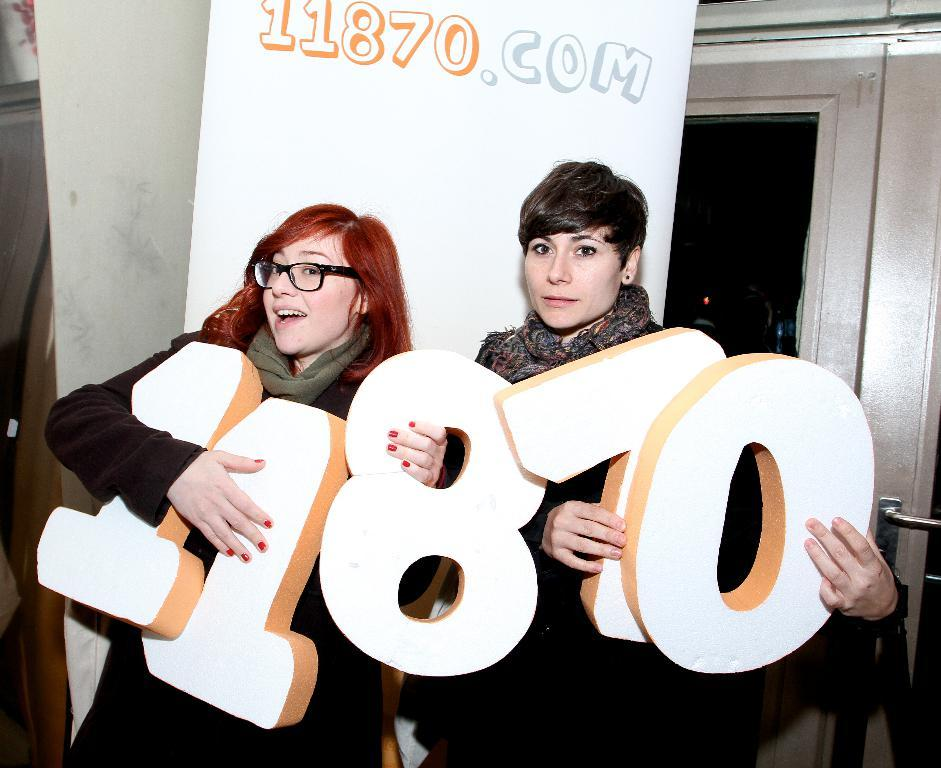Who is present in the image? There are women in the image. What are the women holding in the image? The women are holding depictions of numbers. What can be seen in the background of the image? There are posters and a door in the background of the image. How does the brother in the image help with the number balance? There is no brother present in the image, and therefore no such assistance can be observed. 